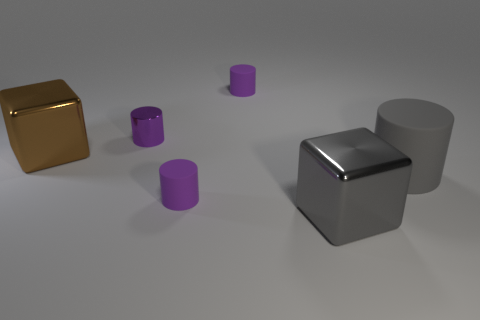Subtract all tiny cylinders. How many cylinders are left? 1 Add 1 large gray metal objects. How many objects exist? 7 Subtract all cubes. How many objects are left? 4 Subtract 3 cylinders. How many cylinders are left? 1 Subtract all cyan balls. How many purple cylinders are left? 3 Subtract all gray cylinders. How many cylinders are left? 3 Subtract all tiny purple rubber things. Subtract all gray cubes. How many objects are left? 3 Add 6 purple rubber objects. How many purple rubber objects are left? 8 Add 6 large purple rubber things. How many large purple rubber things exist? 6 Subtract 0 gray balls. How many objects are left? 6 